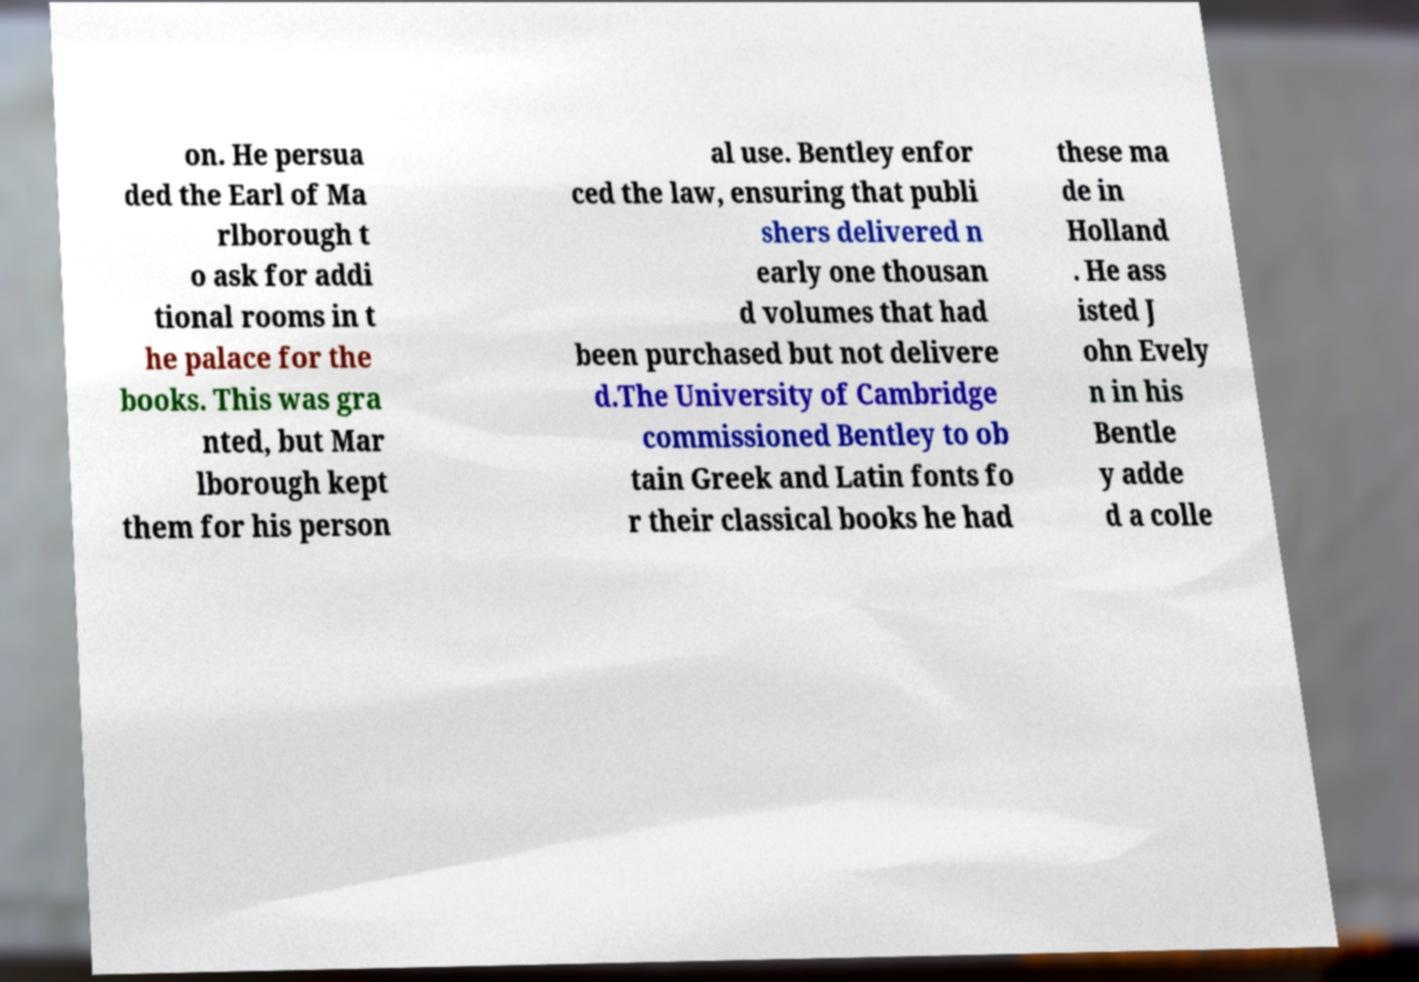Can you accurately transcribe the text from the provided image for me? on. He persua ded the Earl of Ma rlborough t o ask for addi tional rooms in t he palace for the books. This was gra nted, but Mar lborough kept them for his person al use. Bentley enfor ced the law, ensuring that publi shers delivered n early one thousan d volumes that had been purchased but not delivere d.The University of Cambridge commissioned Bentley to ob tain Greek and Latin fonts fo r their classical books he had these ma de in Holland . He ass isted J ohn Evely n in his Bentle y adde d a colle 